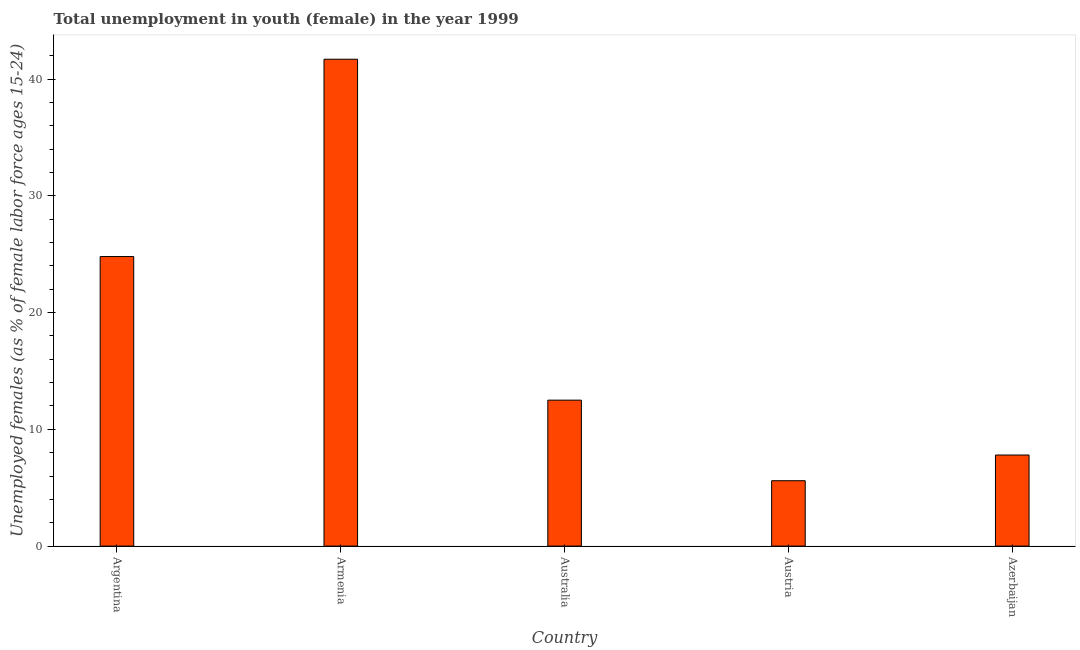What is the title of the graph?
Provide a succinct answer. Total unemployment in youth (female) in the year 1999. What is the label or title of the Y-axis?
Your response must be concise. Unemployed females (as % of female labor force ages 15-24). What is the unemployed female youth population in Argentina?
Offer a very short reply. 24.8. Across all countries, what is the maximum unemployed female youth population?
Provide a short and direct response. 41.7. Across all countries, what is the minimum unemployed female youth population?
Provide a succinct answer. 5.6. In which country was the unemployed female youth population maximum?
Keep it short and to the point. Armenia. What is the sum of the unemployed female youth population?
Offer a terse response. 92.4. What is the difference between the unemployed female youth population in Argentina and Armenia?
Your answer should be compact. -16.9. What is the average unemployed female youth population per country?
Provide a short and direct response. 18.48. What is the median unemployed female youth population?
Ensure brevity in your answer.  12.5. In how many countries, is the unemployed female youth population greater than 38 %?
Offer a very short reply. 1. What is the ratio of the unemployed female youth population in Australia to that in Azerbaijan?
Your answer should be very brief. 1.6. Is the difference between the unemployed female youth population in Armenia and Australia greater than the difference between any two countries?
Make the answer very short. No. What is the difference between the highest and the second highest unemployed female youth population?
Provide a short and direct response. 16.9. What is the difference between the highest and the lowest unemployed female youth population?
Your answer should be very brief. 36.1. In how many countries, is the unemployed female youth population greater than the average unemployed female youth population taken over all countries?
Keep it short and to the point. 2. How many bars are there?
Make the answer very short. 5. Are all the bars in the graph horizontal?
Offer a terse response. No. What is the difference between two consecutive major ticks on the Y-axis?
Ensure brevity in your answer.  10. What is the Unemployed females (as % of female labor force ages 15-24) in Argentina?
Keep it short and to the point. 24.8. What is the Unemployed females (as % of female labor force ages 15-24) of Armenia?
Provide a succinct answer. 41.7. What is the Unemployed females (as % of female labor force ages 15-24) in Australia?
Make the answer very short. 12.5. What is the Unemployed females (as % of female labor force ages 15-24) of Austria?
Give a very brief answer. 5.6. What is the Unemployed females (as % of female labor force ages 15-24) in Azerbaijan?
Provide a succinct answer. 7.8. What is the difference between the Unemployed females (as % of female labor force ages 15-24) in Argentina and Armenia?
Give a very brief answer. -16.9. What is the difference between the Unemployed females (as % of female labor force ages 15-24) in Argentina and Azerbaijan?
Keep it short and to the point. 17. What is the difference between the Unemployed females (as % of female labor force ages 15-24) in Armenia and Australia?
Make the answer very short. 29.2. What is the difference between the Unemployed females (as % of female labor force ages 15-24) in Armenia and Austria?
Your answer should be very brief. 36.1. What is the difference between the Unemployed females (as % of female labor force ages 15-24) in Armenia and Azerbaijan?
Offer a very short reply. 33.9. What is the difference between the Unemployed females (as % of female labor force ages 15-24) in Australia and Austria?
Your response must be concise. 6.9. What is the difference between the Unemployed females (as % of female labor force ages 15-24) in Australia and Azerbaijan?
Make the answer very short. 4.7. What is the ratio of the Unemployed females (as % of female labor force ages 15-24) in Argentina to that in Armenia?
Provide a succinct answer. 0.59. What is the ratio of the Unemployed females (as % of female labor force ages 15-24) in Argentina to that in Australia?
Your answer should be very brief. 1.98. What is the ratio of the Unemployed females (as % of female labor force ages 15-24) in Argentina to that in Austria?
Offer a terse response. 4.43. What is the ratio of the Unemployed females (as % of female labor force ages 15-24) in Argentina to that in Azerbaijan?
Offer a terse response. 3.18. What is the ratio of the Unemployed females (as % of female labor force ages 15-24) in Armenia to that in Australia?
Your answer should be very brief. 3.34. What is the ratio of the Unemployed females (as % of female labor force ages 15-24) in Armenia to that in Austria?
Give a very brief answer. 7.45. What is the ratio of the Unemployed females (as % of female labor force ages 15-24) in Armenia to that in Azerbaijan?
Keep it short and to the point. 5.35. What is the ratio of the Unemployed females (as % of female labor force ages 15-24) in Australia to that in Austria?
Offer a very short reply. 2.23. What is the ratio of the Unemployed females (as % of female labor force ages 15-24) in Australia to that in Azerbaijan?
Your answer should be compact. 1.6. What is the ratio of the Unemployed females (as % of female labor force ages 15-24) in Austria to that in Azerbaijan?
Offer a terse response. 0.72. 